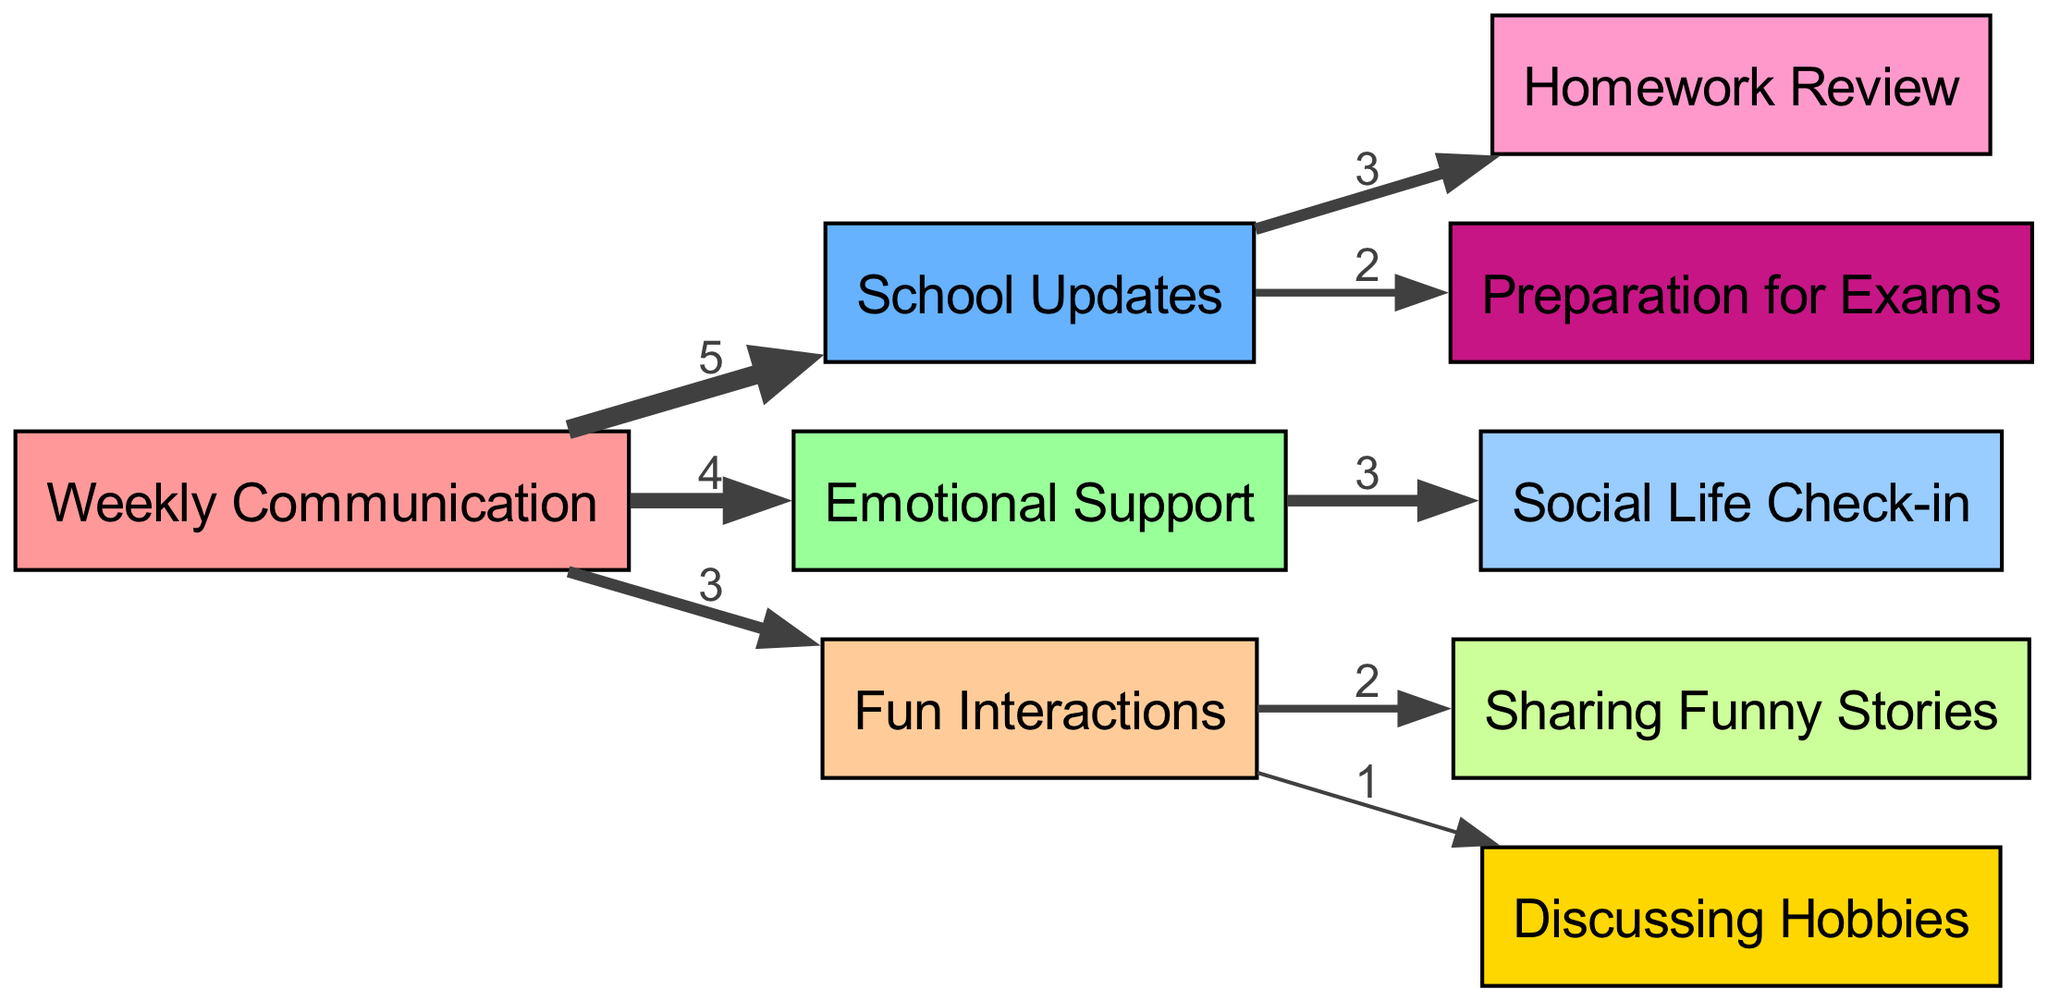How many nodes are in the diagram? The diagram consists of nine distinct nodes, including the main source node "Weekly Communication" and various target nodes categorized under different activities.
Answer: 9 What is the value of the "Emotional Support" link? The "Emotional Support" link has a value of 4, indicating the amount of communication time allocated to this category.
Answer: 4 Which activity has the highest communication time? The activity with the highest communication time is "School Updates," which has a value of 5, indicating it is the most discussed topic during calls.
Answer: School Updates How many links connect to "Fun Interactions"? There are three links connecting to "Fun Interactions," specifically to "Sharing Funny Stories" and "Discussing Hobbies."
Answer: 3 What percentage of total communication is devoted to "Emotional Support"? The total communication time is 5 + 4 + 3 = 12. The "Emotional Support" value is 4, leading to a percentage of (4/12)*100 = 33.33%.
Answer: 33.33% What is the flow from "School Updates" to "Homework Review"? The link from "School Updates" to "Homework Review" has a value of 3, meaning that 3 units of communication time are spent discussing homework.
Answer: 3 Which two activities are connected most with the same value? "Sharing Funny Stories" and "Discussing Hobbies" are both connected to "Fun Interactions," with values of 2 and 1, respectively. However, "Homework Review" also connects from "School Updates" with a value of 3, which is higher.
Answer: Sharing Funny Stories & Discussing Hobbies What amount of communication time is allocated to preparation for exams? The link to "Preparation for Exams" from "School Updates" has a value of 2, meaning 2 units of communication time are allocated to this activity.
Answer: 2 What is the total value of all communication links? To get the total value, sum all values: 5 + 4 + 3 + 3 + 2 + 3 + 2 + 1 = 23. Therefore, the total value of all communication links is 23.
Answer: 23 